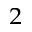<formula> <loc_0><loc_0><loc_500><loc_500>^ { 2 }</formula> 